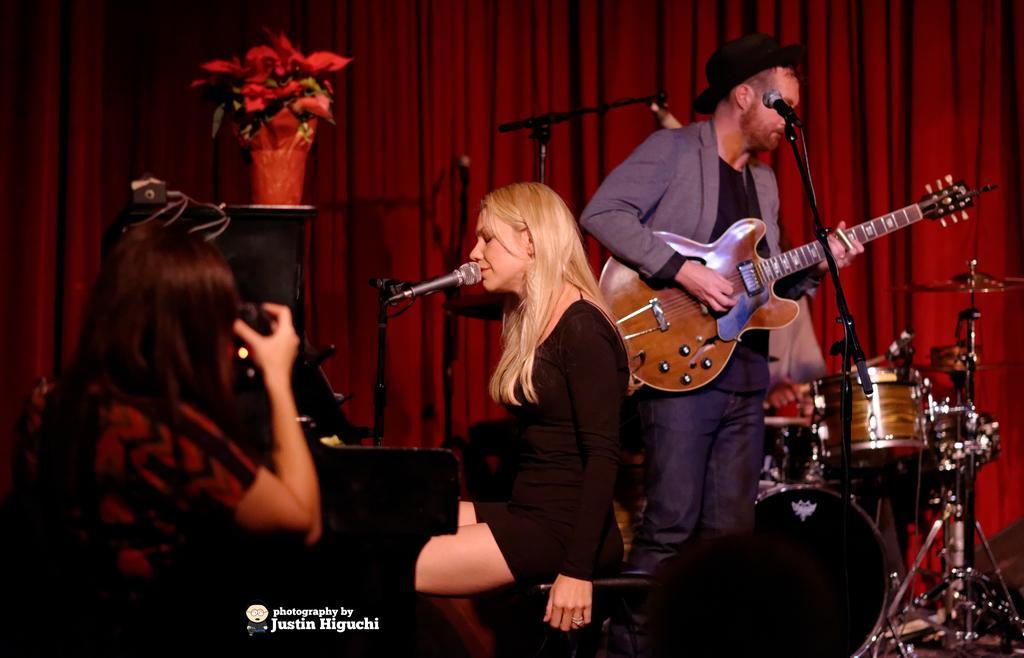In one or two sentences, can you explain what this image depicts? A woman is singing on the microphone. On the right side there is a man who is playing with the guitar. 